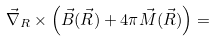<formula> <loc_0><loc_0><loc_500><loc_500>\vec { \nabla } _ { R } \times \left ( \vec { B } ( \vec { R } ) + 4 \pi \vec { M } ( \vec { R } ) \right ) =</formula> 